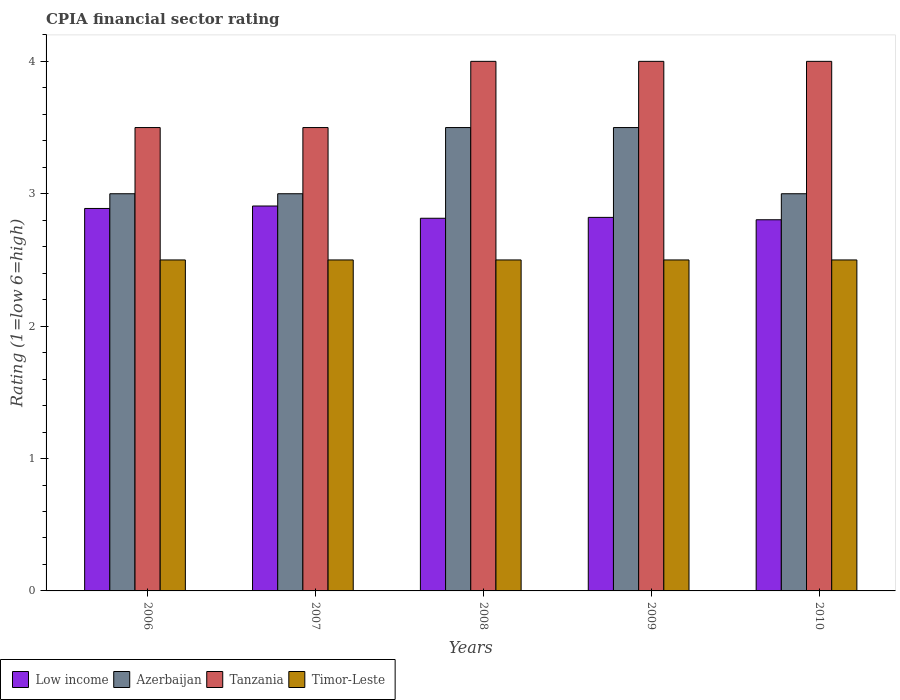Are the number of bars per tick equal to the number of legend labels?
Keep it short and to the point. Yes. Are the number of bars on each tick of the X-axis equal?
Your answer should be very brief. Yes. What is the label of the 2nd group of bars from the left?
Ensure brevity in your answer.  2007. In how many cases, is the number of bars for a given year not equal to the number of legend labels?
Keep it short and to the point. 0. In which year was the CPIA rating in Low income maximum?
Your response must be concise. 2007. What is the total CPIA rating in Timor-Leste in the graph?
Your answer should be very brief. 12.5. What is the difference between the CPIA rating in Tanzania in 2006 and that in 2007?
Give a very brief answer. 0. What is the difference between the CPIA rating in Low income in 2008 and the CPIA rating in Tanzania in 2009?
Your answer should be compact. -1.19. What is the average CPIA rating in Azerbaijan per year?
Your answer should be very brief. 3.2. What is the ratio of the CPIA rating in Azerbaijan in 2008 to that in 2009?
Your answer should be very brief. 1. Is the CPIA rating in Tanzania in 2007 less than that in 2009?
Ensure brevity in your answer.  Yes. Is the difference between the CPIA rating in Timor-Leste in 2006 and 2010 greater than the difference between the CPIA rating in Azerbaijan in 2006 and 2010?
Offer a terse response. No. What does the 2nd bar from the left in 2006 represents?
Ensure brevity in your answer.  Azerbaijan. What does the 1st bar from the right in 2009 represents?
Your answer should be compact. Timor-Leste. Is it the case that in every year, the sum of the CPIA rating in Low income and CPIA rating in Timor-Leste is greater than the CPIA rating in Azerbaijan?
Make the answer very short. Yes. Are all the bars in the graph horizontal?
Keep it short and to the point. No. How many years are there in the graph?
Provide a short and direct response. 5. What is the difference between two consecutive major ticks on the Y-axis?
Your answer should be compact. 1. Are the values on the major ticks of Y-axis written in scientific E-notation?
Provide a succinct answer. No. Does the graph contain any zero values?
Your answer should be compact. No. Where does the legend appear in the graph?
Your answer should be compact. Bottom left. How many legend labels are there?
Keep it short and to the point. 4. What is the title of the graph?
Offer a terse response. CPIA financial sector rating. Does "Europe(developing only)" appear as one of the legend labels in the graph?
Ensure brevity in your answer.  No. What is the Rating (1=low 6=high) of Low income in 2006?
Provide a short and direct response. 2.89. What is the Rating (1=low 6=high) in Azerbaijan in 2006?
Your answer should be very brief. 3. What is the Rating (1=low 6=high) of Tanzania in 2006?
Your answer should be very brief. 3.5. What is the Rating (1=low 6=high) in Timor-Leste in 2006?
Keep it short and to the point. 2.5. What is the Rating (1=low 6=high) of Low income in 2007?
Keep it short and to the point. 2.91. What is the Rating (1=low 6=high) in Timor-Leste in 2007?
Your answer should be compact. 2.5. What is the Rating (1=low 6=high) in Low income in 2008?
Give a very brief answer. 2.81. What is the Rating (1=low 6=high) in Azerbaijan in 2008?
Offer a terse response. 3.5. What is the Rating (1=low 6=high) in Low income in 2009?
Make the answer very short. 2.82. What is the Rating (1=low 6=high) of Azerbaijan in 2009?
Your answer should be very brief. 3.5. What is the Rating (1=low 6=high) in Tanzania in 2009?
Offer a very short reply. 4. What is the Rating (1=low 6=high) of Low income in 2010?
Provide a short and direct response. 2.8. What is the Rating (1=low 6=high) of Azerbaijan in 2010?
Your answer should be compact. 3. Across all years, what is the maximum Rating (1=low 6=high) of Low income?
Provide a short and direct response. 2.91. Across all years, what is the minimum Rating (1=low 6=high) in Low income?
Provide a succinct answer. 2.8. Across all years, what is the minimum Rating (1=low 6=high) in Tanzania?
Keep it short and to the point. 3.5. Across all years, what is the minimum Rating (1=low 6=high) of Timor-Leste?
Offer a very short reply. 2.5. What is the total Rating (1=low 6=high) of Low income in the graph?
Your answer should be compact. 14.24. What is the total Rating (1=low 6=high) in Tanzania in the graph?
Offer a very short reply. 19. What is the total Rating (1=low 6=high) of Timor-Leste in the graph?
Offer a terse response. 12.5. What is the difference between the Rating (1=low 6=high) in Low income in 2006 and that in 2007?
Your response must be concise. -0.02. What is the difference between the Rating (1=low 6=high) in Tanzania in 2006 and that in 2007?
Your answer should be compact. 0. What is the difference between the Rating (1=low 6=high) in Low income in 2006 and that in 2008?
Provide a succinct answer. 0.07. What is the difference between the Rating (1=low 6=high) of Timor-Leste in 2006 and that in 2008?
Your answer should be very brief. 0. What is the difference between the Rating (1=low 6=high) in Low income in 2006 and that in 2009?
Your answer should be very brief. 0.07. What is the difference between the Rating (1=low 6=high) of Tanzania in 2006 and that in 2009?
Ensure brevity in your answer.  -0.5. What is the difference between the Rating (1=low 6=high) in Low income in 2006 and that in 2010?
Provide a short and direct response. 0.09. What is the difference between the Rating (1=low 6=high) of Low income in 2007 and that in 2008?
Provide a short and direct response. 0.09. What is the difference between the Rating (1=low 6=high) of Azerbaijan in 2007 and that in 2008?
Make the answer very short. -0.5. What is the difference between the Rating (1=low 6=high) in Tanzania in 2007 and that in 2008?
Your answer should be compact. -0.5. What is the difference between the Rating (1=low 6=high) in Timor-Leste in 2007 and that in 2008?
Your answer should be compact. 0. What is the difference between the Rating (1=low 6=high) of Low income in 2007 and that in 2009?
Give a very brief answer. 0.09. What is the difference between the Rating (1=low 6=high) of Tanzania in 2007 and that in 2009?
Provide a short and direct response. -0.5. What is the difference between the Rating (1=low 6=high) in Timor-Leste in 2007 and that in 2009?
Ensure brevity in your answer.  0. What is the difference between the Rating (1=low 6=high) in Low income in 2007 and that in 2010?
Make the answer very short. 0.1. What is the difference between the Rating (1=low 6=high) in Tanzania in 2007 and that in 2010?
Provide a succinct answer. -0.5. What is the difference between the Rating (1=low 6=high) in Low income in 2008 and that in 2009?
Offer a very short reply. -0.01. What is the difference between the Rating (1=low 6=high) of Tanzania in 2008 and that in 2009?
Keep it short and to the point. 0. What is the difference between the Rating (1=low 6=high) of Low income in 2008 and that in 2010?
Keep it short and to the point. 0.01. What is the difference between the Rating (1=low 6=high) of Azerbaijan in 2008 and that in 2010?
Your answer should be compact. 0.5. What is the difference between the Rating (1=low 6=high) of Tanzania in 2008 and that in 2010?
Give a very brief answer. 0. What is the difference between the Rating (1=low 6=high) of Low income in 2009 and that in 2010?
Offer a very short reply. 0.02. What is the difference between the Rating (1=low 6=high) of Timor-Leste in 2009 and that in 2010?
Ensure brevity in your answer.  0. What is the difference between the Rating (1=low 6=high) in Low income in 2006 and the Rating (1=low 6=high) in Azerbaijan in 2007?
Provide a short and direct response. -0.11. What is the difference between the Rating (1=low 6=high) in Low income in 2006 and the Rating (1=low 6=high) in Tanzania in 2007?
Make the answer very short. -0.61. What is the difference between the Rating (1=low 6=high) in Low income in 2006 and the Rating (1=low 6=high) in Timor-Leste in 2007?
Keep it short and to the point. 0.39. What is the difference between the Rating (1=low 6=high) of Azerbaijan in 2006 and the Rating (1=low 6=high) of Tanzania in 2007?
Your answer should be compact. -0.5. What is the difference between the Rating (1=low 6=high) in Tanzania in 2006 and the Rating (1=low 6=high) in Timor-Leste in 2007?
Provide a short and direct response. 1. What is the difference between the Rating (1=low 6=high) in Low income in 2006 and the Rating (1=low 6=high) in Azerbaijan in 2008?
Keep it short and to the point. -0.61. What is the difference between the Rating (1=low 6=high) of Low income in 2006 and the Rating (1=low 6=high) of Tanzania in 2008?
Make the answer very short. -1.11. What is the difference between the Rating (1=low 6=high) in Low income in 2006 and the Rating (1=low 6=high) in Timor-Leste in 2008?
Give a very brief answer. 0.39. What is the difference between the Rating (1=low 6=high) of Azerbaijan in 2006 and the Rating (1=low 6=high) of Timor-Leste in 2008?
Your answer should be compact. 0.5. What is the difference between the Rating (1=low 6=high) of Tanzania in 2006 and the Rating (1=low 6=high) of Timor-Leste in 2008?
Ensure brevity in your answer.  1. What is the difference between the Rating (1=low 6=high) of Low income in 2006 and the Rating (1=low 6=high) of Azerbaijan in 2009?
Your answer should be compact. -0.61. What is the difference between the Rating (1=low 6=high) of Low income in 2006 and the Rating (1=low 6=high) of Tanzania in 2009?
Keep it short and to the point. -1.11. What is the difference between the Rating (1=low 6=high) of Low income in 2006 and the Rating (1=low 6=high) of Timor-Leste in 2009?
Keep it short and to the point. 0.39. What is the difference between the Rating (1=low 6=high) in Azerbaijan in 2006 and the Rating (1=low 6=high) in Timor-Leste in 2009?
Ensure brevity in your answer.  0.5. What is the difference between the Rating (1=low 6=high) of Tanzania in 2006 and the Rating (1=low 6=high) of Timor-Leste in 2009?
Provide a short and direct response. 1. What is the difference between the Rating (1=low 6=high) of Low income in 2006 and the Rating (1=low 6=high) of Azerbaijan in 2010?
Provide a short and direct response. -0.11. What is the difference between the Rating (1=low 6=high) of Low income in 2006 and the Rating (1=low 6=high) of Tanzania in 2010?
Give a very brief answer. -1.11. What is the difference between the Rating (1=low 6=high) in Low income in 2006 and the Rating (1=low 6=high) in Timor-Leste in 2010?
Provide a succinct answer. 0.39. What is the difference between the Rating (1=low 6=high) in Azerbaijan in 2006 and the Rating (1=low 6=high) in Timor-Leste in 2010?
Provide a succinct answer. 0.5. What is the difference between the Rating (1=low 6=high) of Low income in 2007 and the Rating (1=low 6=high) of Azerbaijan in 2008?
Make the answer very short. -0.59. What is the difference between the Rating (1=low 6=high) of Low income in 2007 and the Rating (1=low 6=high) of Tanzania in 2008?
Offer a very short reply. -1.09. What is the difference between the Rating (1=low 6=high) in Low income in 2007 and the Rating (1=low 6=high) in Timor-Leste in 2008?
Your answer should be very brief. 0.41. What is the difference between the Rating (1=low 6=high) in Azerbaijan in 2007 and the Rating (1=low 6=high) in Tanzania in 2008?
Offer a very short reply. -1. What is the difference between the Rating (1=low 6=high) in Low income in 2007 and the Rating (1=low 6=high) in Azerbaijan in 2009?
Offer a terse response. -0.59. What is the difference between the Rating (1=low 6=high) in Low income in 2007 and the Rating (1=low 6=high) in Tanzania in 2009?
Ensure brevity in your answer.  -1.09. What is the difference between the Rating (1=low 6=high) in Low income in 2007 and the Rating (1=low 6=high) in Timor-Leste in 2009?
Provide a succinct answer. 0.41. What is the difference between the Rating (1=low 6=high) of Tanzania in 2007 and the Rating (1=low 6=high) of Timor-Leste in 2009?
Keep it short and to the point. 1. What is the difference between the Rating (1=low 6=high) in Low income in 2007 and the Rating (1=low 6=high) in Azerbaijan in 2010?
Your response must be concise. -0.09. What is the difference between the Rating (1=low 6=high) in Low income in 2007 and the Rating (1=low 6=high) in Tanzania in 2010?
Provide a succinct answer. -1.09. What is the difference between the Rating (1=low 6=high) of Low income in 2007 and the Rating (1=low 6=high) of Timor-Leste in 2010?
Ensure brevity in your answer.  0.41. What is the difference between the Rating (1=low 6=high) in Tanzania in 2007 and the Rating (1=low 6=high) in Timor-Leste in 2010?
Offer a terse response. 1. What is the difference between the Rating (1=low 6=high) in Low income in 2008 and the Rating (1=low 6=high) in Azerbaijan in 2009?
Offer a terse response. -0.69. What is the difference between the Rating (1=low 6=high) in Low income in 2008 and the Rating (1=low 6=high) in Tanzania in 2009?
Ensure brevity in your answer.  -1.19. What is the difference between the Rating (1=low 6=high) of Low income in 2008 and the Rating (1=low 6=high) of Timor-Leste in 2009?
Offer a terse response. 0.31. What is the difference between the Rating (1=low 6=high) in Azerbaijan in 2008 and the Rating (1=low 6=high) in Timor-Leste in 2009?
Offer a terse response. 1. What is the difference between the Rating (1=low 6=high) in Tanzania in 2008 and the Rating (1=low 6=high) in Timor-Leste in 2009?
Provide a succinct answer. 1.5. What is the difference between the Rating (1=low 6=high) in Low income in 2008 and the Rating (1=low 6=high) in Azerbaijan in 2010?
Ensure brevity in your answer.  -0.19. What is the difference between the Rating (1=low 6=high) of Low income in 2008 and the Rating (1=low 6=high) of Tanzania in 2010?
Offer a very short reply. -1.19. What is the difference between the Rating (1=low 6=high) of Low income in 2008 and the Rating (1=low 6=high) of Timor-Leste in 2010?
Offer a terse response. 0.31. What is the difference between the Rating (1=low 6=high) of Azerbaijan in 2008 and the Rating (1=low 6=high) of Tanzania in 2010?
Provide a succinct answer. -0.5. What is the difference between the Rating (1=low 6=high) of Low income in 2009 and the Rating (1=low 6=high) of Azerbaijan in 2010?
Provide a succinct answer. -0.18. What is the difference between the Rating (1=low 6=high) in Low income in 2009 and the Rating (1=low 6=high) in Tanzania in 2010?
Give a very brief answer. -1.18. What is the difference between the Rating (1=low 6=high) of Low income in 2009 and the Rating (1=low 6=high) of Timor-Leste in 2010?
Offer a terse response. 0.32. What is the difference between the Rating (1=low 6=high) of Tanzania in 2009 and the Rating (1=low 6=high) of Timor-Leste in 2010?
Provide a succinct answer. 1.5. What is the average Rating (1=low 6=high) of Low income per year?
Provide a short and direct response. 2.85. In the year 2006, what is the difference between the Rating (1=low 6=high) in Low income and Rating (1=low 6=high) in Azerbaijan?
Make the answer very short. -0.11. In the year 2006, what is the difference between the Rating (1=low 6=high) of Low income and Rating (1=low 6=high) of Tanzania?
Offer a terse response. -0.61. In the year 2006, what is the difference between the Rating (1=low 6=high) of Low income and Rating (1=low 6=high) of Timor-Leste?
Provide a short and direct response. 0.39. In the year 2006, what is the difference between the Rating (1=low 6=high) of Azerbaijan and Rating (1=low 6=high) of Tanzania?
Give a very brief answer. -0.5. In the year 2007, what is the difference between the Rating (1=low 6=high) in Low income and Rating (1=low 6=high) in Azerbaijan?
Make the answer very short. -0.09. In the year 2007, what is the difference between the Rating (1=low 6=high) in Low income and Rating (1=low 6=high) in Tanzania?
Your answer should be very brief. -0.59. In the year 2007, what is the difference between the Rating (1=low 6=high) of Low income and Rating (1=low 6=high) of Timor-Leste?
Offer a terse response. 0.41. In the year 2007, what is the difference between the Rating (1=low 6=high) of Azerbaijan and Rating (1=low 6=high) of Tanzania?
Give a very brief answer. -0.5. In the year 2007, what is the difference between the Rating (1=low 6=high) in Tanzania and Rating (1=low 6=high) in Timor-Leste?
Ensure brevity in your answer.  1. In the year 2008, what is the difference between the Rating (1=low 6=high) of Low income and Rating (1=low 6=high) of Azerbaijan?
Your response must be concise. -0.69. In the year 2008, what is the difference between the Rating (1=low 6=high) of Low income and Rating (1=low 6=high) of Tanzania?
Offer a terse response. -1.19. In the year 2008, what is the difference between the Rating (1=low 6=high) of Low income and Rating (1=low 6=high) of Timor-Leste?
Make the answer very short. 0.31. In the year 2008, what is the difference between the Rating (1=low 6=high) in Azerbaijan and Rating (1=low 6=high) in Tanzania?
Make the answer very short. -0.5. In the year 2008, what is the difference between the Rating (1=low 6=high) of Azerbaijan and Rating (1=low 6=high) of Timor-Leste?
Your answer should be compact. 1. In the year 2008, what is the difference between the Rating (1=low 6=high) of Tanzania and Rating (1=low 6=high) of Timor-Leste?
Offer a very short reply. 1.5. In the year 2009, what is the difference between the Rating (1=low 6=high) of Low income and Rating (1=low 6=high) of Azerbaijan?
Your answer should be very brief. -0.68. In the year 2009, what is the difference between the Rating (1=low 6=high) in Low income and Rating (1=low 6=high) in Tanzania?
Your response must be concise. -1.18. In the year 2009, what is the difference between the Rating (1=low 6=high) in Low income and Rating (1=low 6=high) in Timor-Leste?
Offer a terse response. 0.32. In the year 2009, what is the difference between the Rating (1=low 6=high) of Azerbaijan and Rating (1=low 6=high) of Tanzania?
Ensure brevity in your answer.  -0.5. In the year 2009, what is the difference between the Rating (1=low 6=high) of Azerbaijan and Rating (1=low 6=high) of Timor-Leste?
Provide a short and direct response. 1. In the year 2009, what is the difference between the Rating (1=low 6=high) of Tanzania and Rating (1=low 6=high) of Timor-Leste?
Your answer should be compact. 1.5. In the year 2010, what is the difference between the Rating (1=low 6=high) of Low income and Rating (1=low 6=high) of Azerbaijan?
Keep it short and to the point. -0.2. In the year 2010, what is the difference between the Rating (1=low 6=high) in Low income and Rating (1=low 6=high) in Tanzania?
Your answer should be very brief. -1.2. In the year 2010, what is the difference between the Rating (1=low 6=high) of Low income and Rating (1=low 6=high) of Timor-Leste?
Offer a terse response. 0.3. In the year 2010, what is the difference between the Rating (1=low 6=high) in Azerbaijan and Rating (1=low 6=high) in Tanzania?
Your answer should be very brief. -1. In the year 2010, what is the difference between the Rating (1=low 6=high) of Tanzania and Rating (1=low 6=high) of Timor-Leste?
Your answer should be very brief. 1.5. What is the ratio of the Rating (1=low 6=high) in Timor-Leste in 2006 to that in 2007?
Your answer should be very brief. 1. What is the ratio of the Rating (1=low 6=high) in Low income in 2006 to that in 2008?
Keep it short and to the point. 1.03. What is the ratio of the Rating (1=low 6=high) in Azerbaijan in 2006 to that in 2008?
Offer a terse response. 0.86. What is the ratio of the Rating (1=low 6=high) of Tanzania in 2006 to that in 2008?
Give a very brief answer. 0.88. What is the ratio of the Rating (1=low 6=high) of Low income in 2006 to that in 2009?
Your response must be concise. 1.02. What is the ratio of the Rating (1=low 6=high) in Timor-Leste in 2006 to that in 2009?
Ensure brevity in your answer.  1. What is the ratio of the Rating (1=low 6=high) in Low income in 2006 to that in 2010?
Offer a terse response. 1.03. What is the ratio of the Rating (1=low 6=high) in Azerbaijan in 2006 to that in 2010?
Keep it short and to the point. 1. What is the ratio of the Rating (1=low 6=high) in Tanzania in 2006 to that in 2010?
Give a very brief answer. 0.88. What is the ratio of the Rating (1=low 6=high) of Timor-Leste in 2006 to that in 2010?
Provide a short and direct response. 1. What is the ratio of the Rating (1=low 6=high) in Low income in 2007 to that in 2008?
Give a very brief answer. 1.03. What is the ratio of the Rating (1=low 6=high) in Tanzania in 2007 to that in 2008?
Provide a succinct answer. 0.88. What is the ratio of the Rating (1=low 6=high) of Timor-Leste in 2007 to that in 2008?
Keep it short and to the point. 1. What is the ratio of the Rating (1=low 6=high) in Low income in 2007 to that in 2009?
Offer a very short reply. 1.03. What is the ratio of the Rating (1=low 6=high) in Azerbaijan in 2007 to that in 2009?
Give a very brief answer. 0.86. What is the ratio of the Rating (1=low 6=high) of Timor-Leste in 2007 to that in 2009?
Offer a very short reply. 1. What is the ratio of the Rating (1=low 6=high) in Low income in 2007 to that in 2010?
Offer a terse response. 1.04. What is the ratio of the Rating (1=low 6=high) in Tanzania in 2007 to that in 2010?
Provide a succinct answer. 0.88. What is the ratio of the Rating (1=low 6=high) of Timor-Leste in 2007 to that in 2010?
Give a very brief answer. 1. What is the ratio of the Rating (1=low 6=high) in Low income in 2008 to that in 2009?
Keep it short and to the point. 1. What is the ratio of the Rating (1=low 6=high) of Azerbaijan in 2008 to that in 2009?
Keep it short and to the point. 1. What is the ratio of the Rating (1=low 6=high) of Tanzania in 2008 to that in 2009?
Give a very brief answer. 1. What is the ratio of the Rating (1=low 6=high) of Timor-Leste in 2008 to that in 2009?
Offer a terse response. 1. What is the ratio of the Rating (1=low 6=high) in Azerbaijan in 2008 to that in 2010?
Your answer should be very brief. 1.17. What is the ratio of the Rating (1=low 6=high) in Low income in 2009 to that in 2010?
Your answer should be compact. 1.01. What is the ratio of the Rating (1=low 6=high) of Azerbaijan in 2009 to that in 2010?
Provide a succinct answer. 1.17. What is the ratio of the Rating (1=low 6=high) of Tanzania in 2009 to that in 2010?
Offer a terse response. 1. What is the ratio of the Rating (1=low 6=high) in Timor-Leste in 2009 to that in 2010?
Offer a terse response. 1. What is the difference between the highest and the second highest Rating (1=low 6=high) in Low income?
Provide a short and direct response. 0.02. What is the difference between the highest and the second highest Rating (1=low 6=high) in Azerbaijan?
Your response must be concise. 0. What is the difference between the highest and the second highest Rating (1=low 6=high) in Timor-Leste?
Your answer should be compact. 0. What is the difference between the highest and the lowest Rating (1=low 6=high) of Low income?
Make the answer very short. 0.1. What is the difference between the highest and the lowest Rating (1=low 6=high) in Tanzania?
Ensure brevity in your answer.  0.5. 